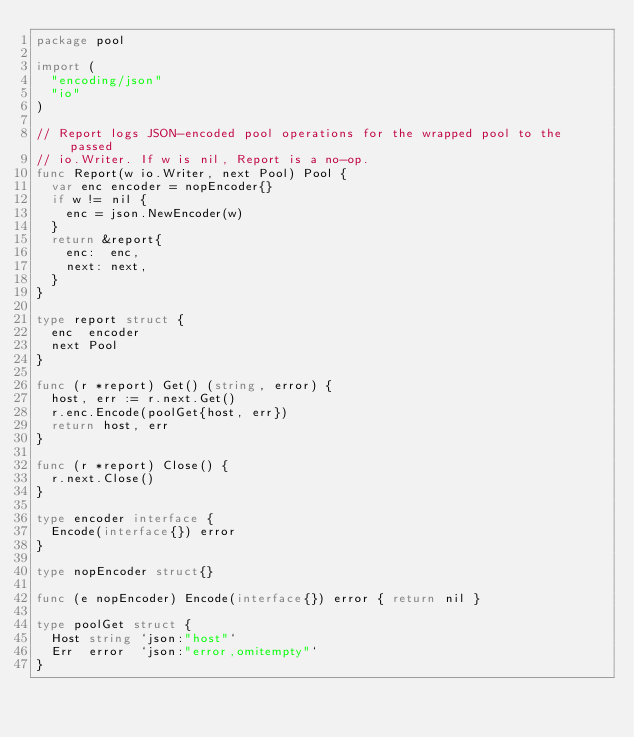Convert code to text. <code><loc_0><loc_0><loc_500><loc_500><_Go_>package pool

import (
	"encoding/json"
	"io"
)

// Report logs JSON-encoded pool operations for the wrapped pool to the passed
// io.Writer. If w is nil, Report is a no-op.
func Report(w io.Writer, next Pool) Pool {
	var enc encoder = nopEncoder{}
	if w != nil {
		enc = json.NewEncoder(w)
	}
	return &report{
		enc:  enc,
		next: next,
	}
}

type report struct {
	enc  encoder
	next Pool
}

func (r *report) Get() (string, error) {
	host, err := r.next.Get()
	r.enc.Encode(poolGet{host, err})
	return host, err
}

func (r *report) Close() {
	r.next.Close()
}

type encoder interface {
	Encode(interface{}) error
}

type nopEncoder struct{}

func (e nopEncoder) Encode(interface{}) error { return nil }

type poolGet struct {
	Host string `json:"host"`
	Err  error  `json:"error,omitempty"`
}
</code> 